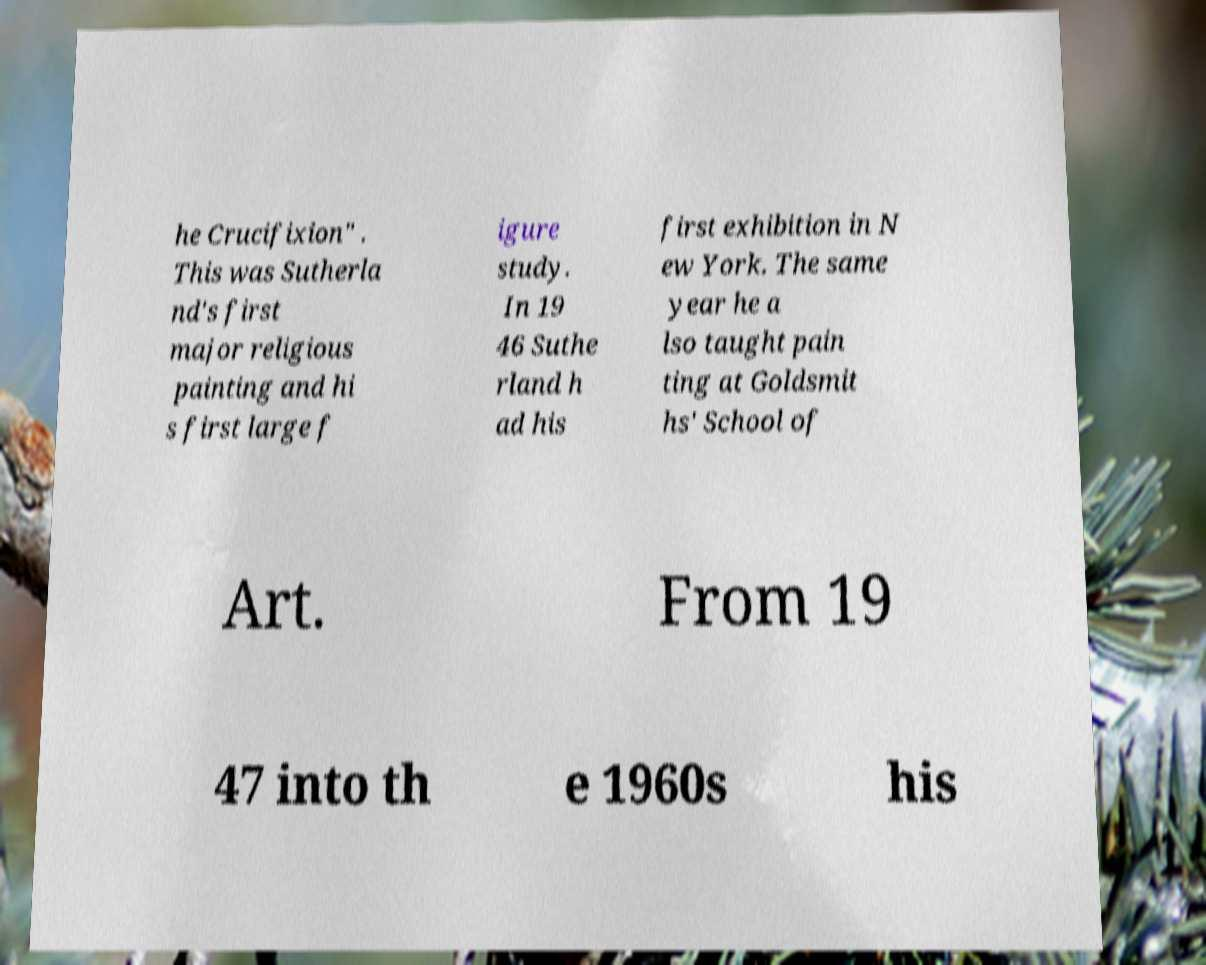Could you extract and type out the text from this image? he Crucifixion" . This was Sutherla nd's first major religious painting and hi s first large f igure study. In 19 46 Suthe rland h ad his first exhibition in N ew York. The same year he a lso taught pain ting at Goldsmit hs' School of Art. From 19 47 into th e 1960s his 